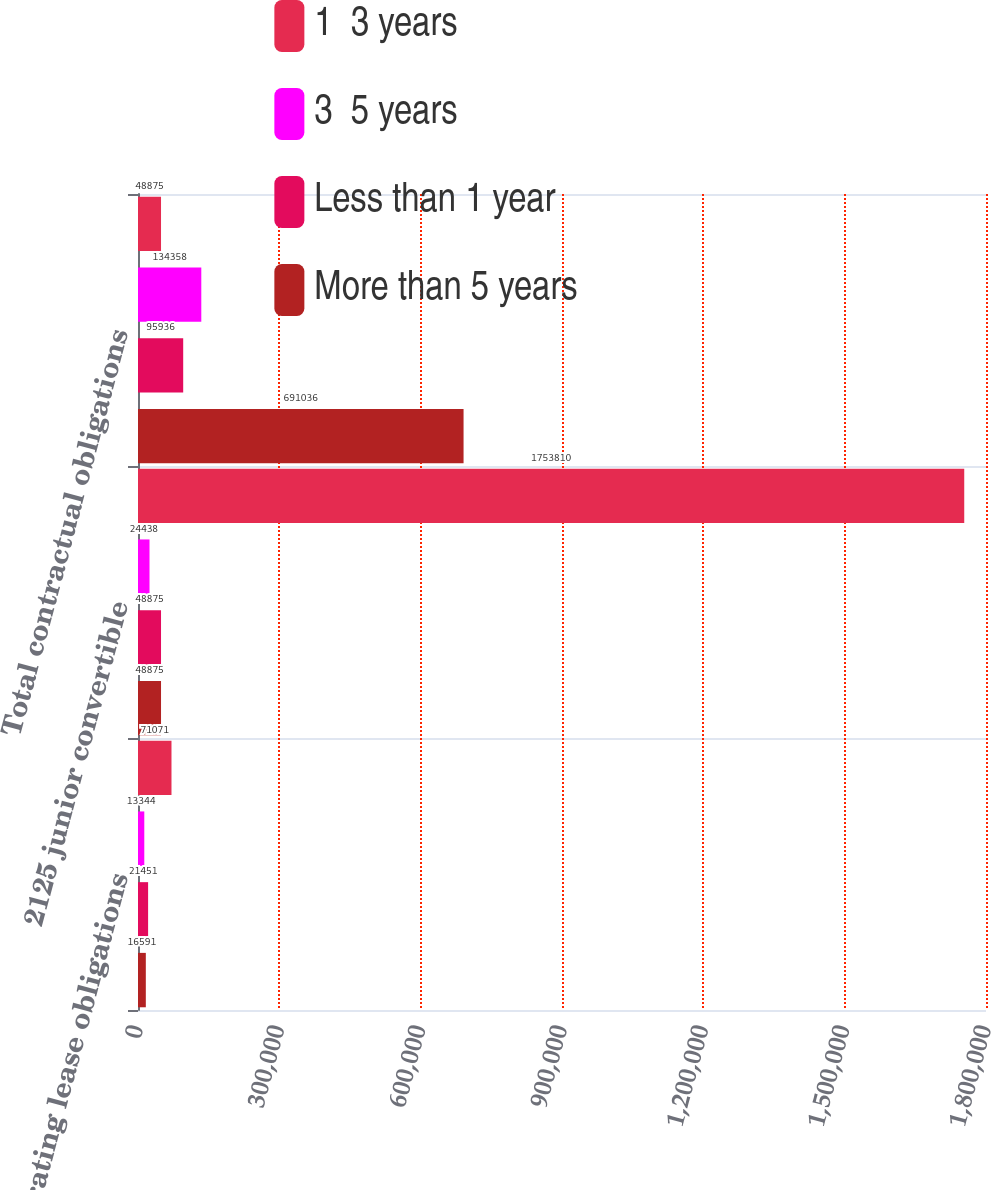Convert chart. <chart><loc_0><loc_0><loc_500><loc_500><stacked_bar_chart><ecel><fcel>Operating lease obligations<fcel>2125 junior convertible<fcel>Total contractual obligations<nl><fcel>1  3 years<fcel>71071<fcel>1.75381e+06<fcel>48875<nl><fcel>3  5 years<fcel>13344<fcel>24438<fcel>134358<nl><fcel>Less than 1 year<fcel>21451<fcel>48875<fcel>95936<nl><fcel>More than 5 years<fcel>16591<fcel>48875<fcel>691036<nl></chart> 